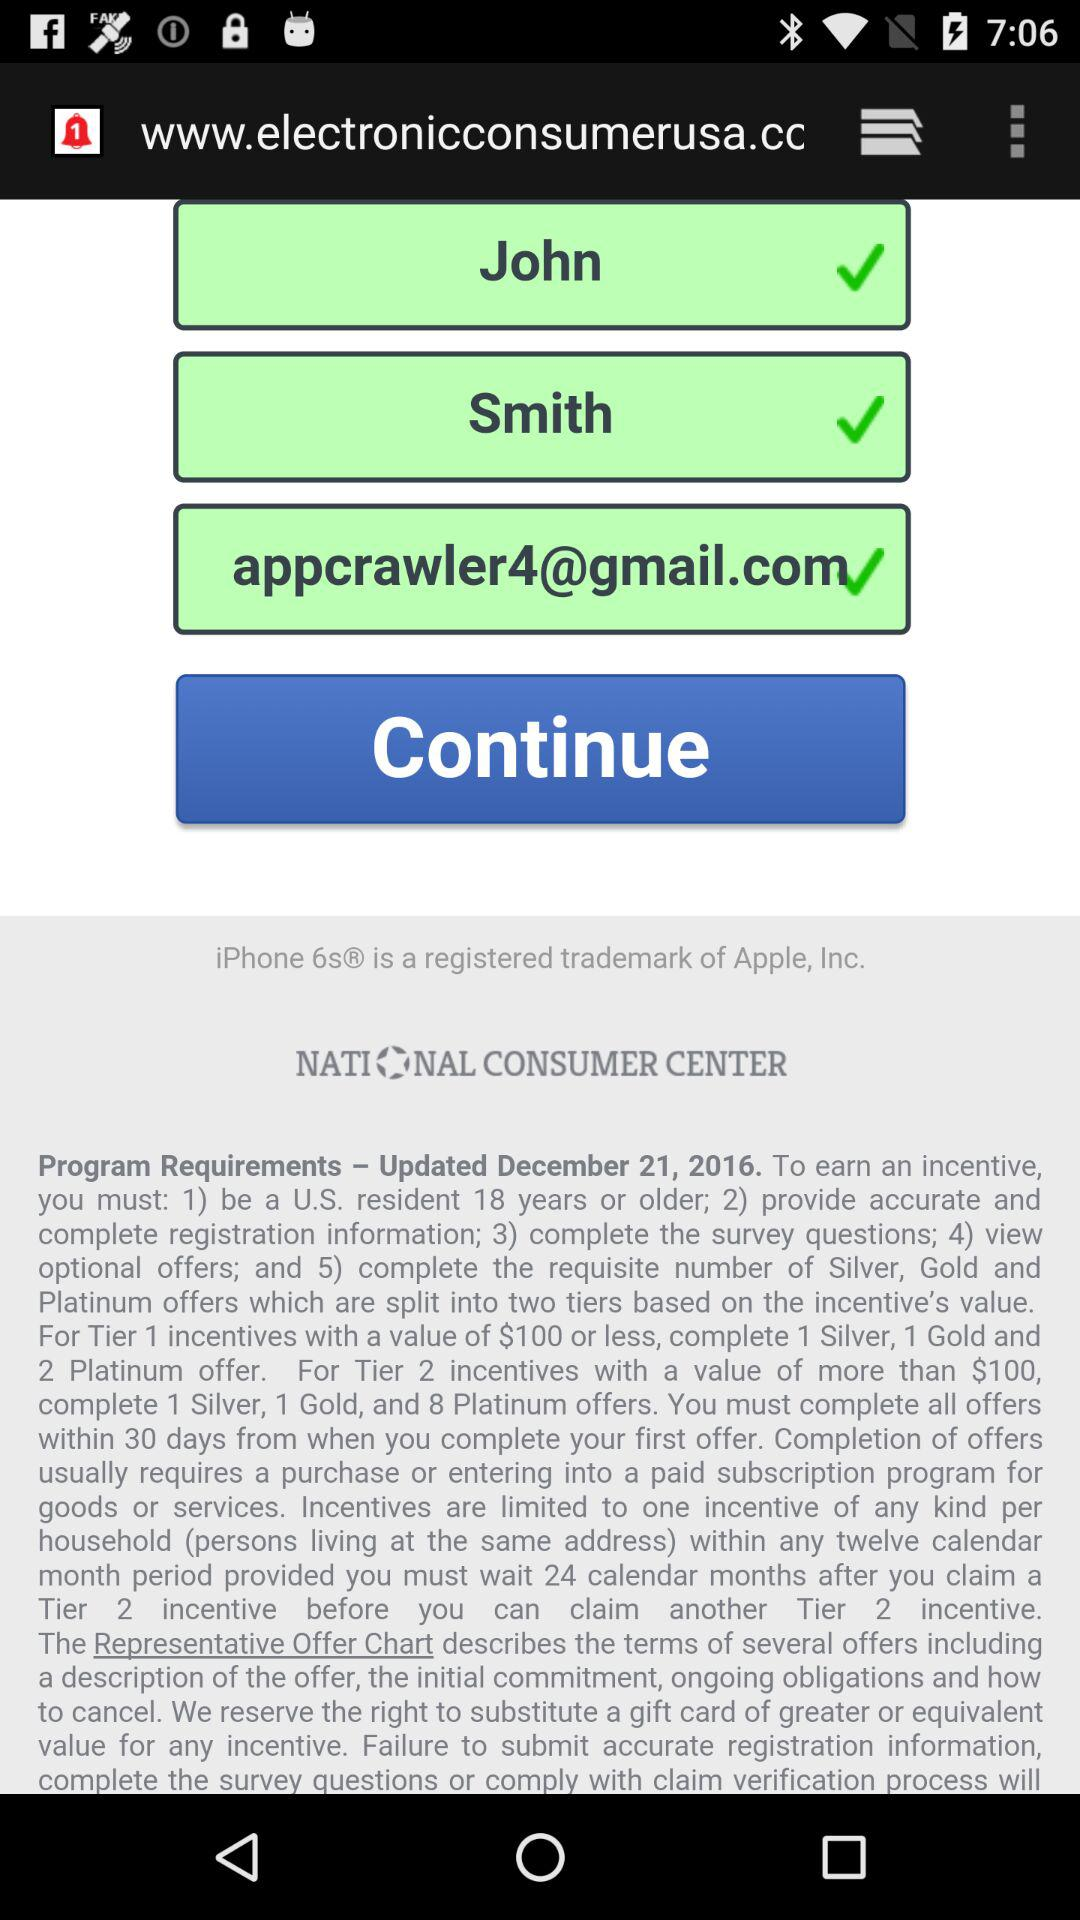What is the email address? The email address is appcrawler4@gmail.com. 